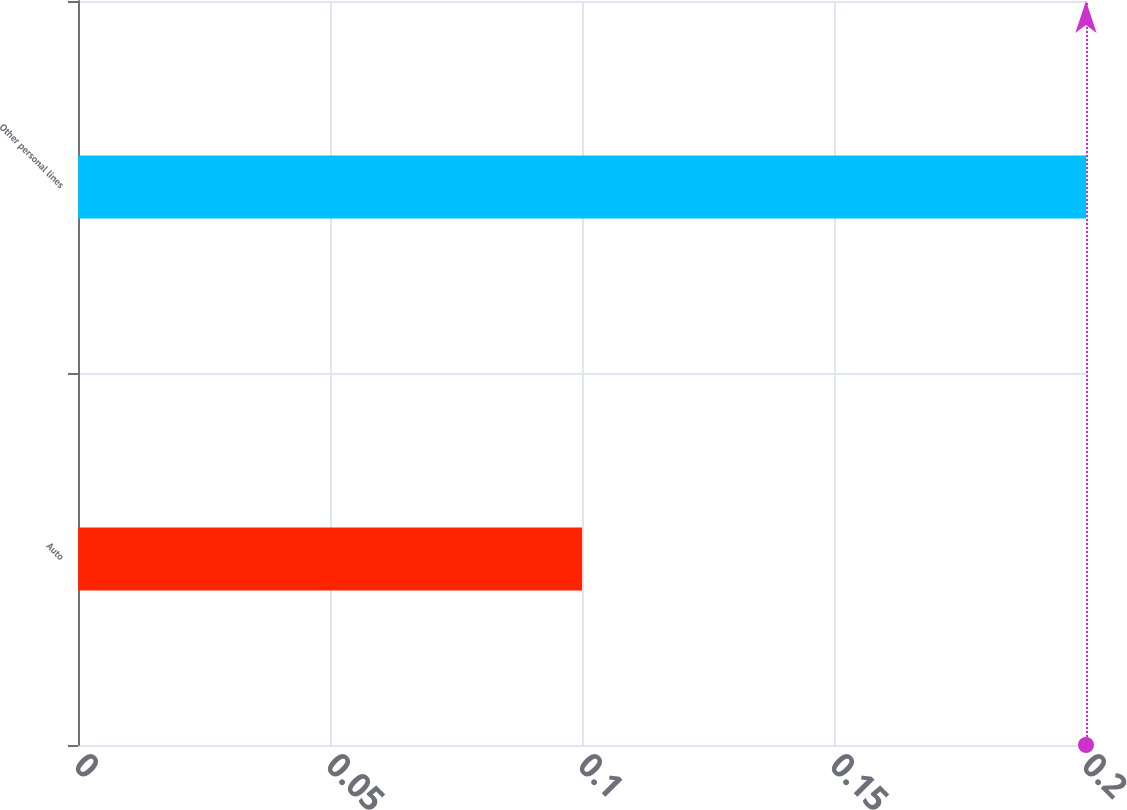Convert chart. <chart><loc_0><loc_0><loc_500><loc_500><bar_chart><fcel>Auto<fcel>Other personal lines<nl><fcel>0.1<fcel>0.2<nl></chart> 